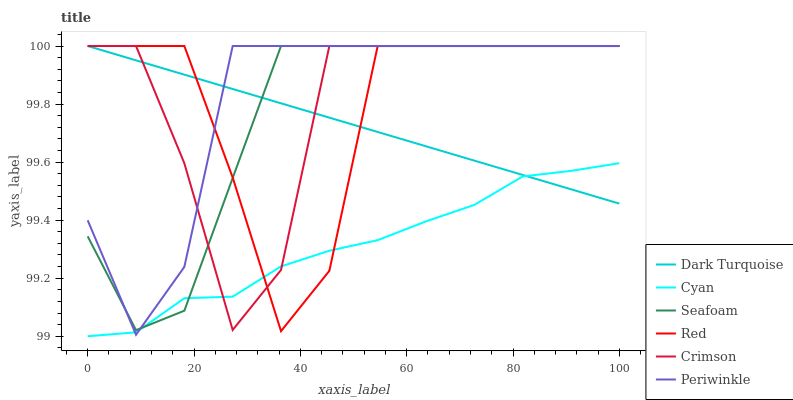Does Seafoam have the minimum area under the curve?
Answer yes or no. No. Does Seafoam have the maximum area under the curve?
Answer yes or no. No. Is Seafoam the smoothest?
Answer yes or no. No. Is Seafoam the roughest?
Answer yes or no. No. Does Seafoam have the lowest value?
Answer yes or no. No. Does Cyan have the highest value?
Answer yes or no. No. 